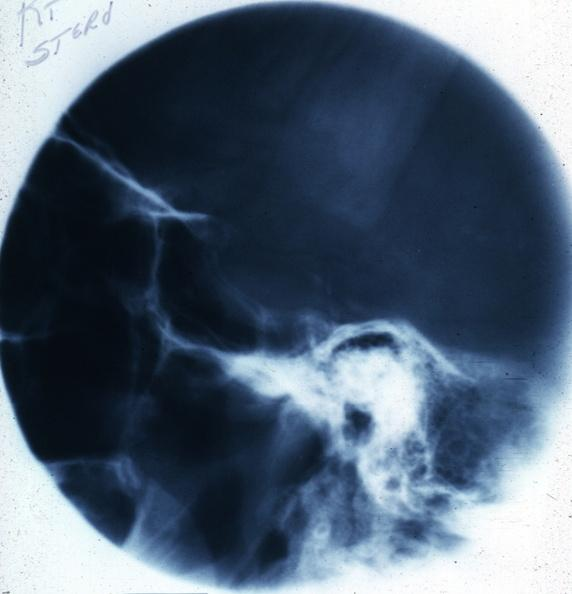what is present?
Answer the question using a single word or phrase. Chromophobe adenoma 